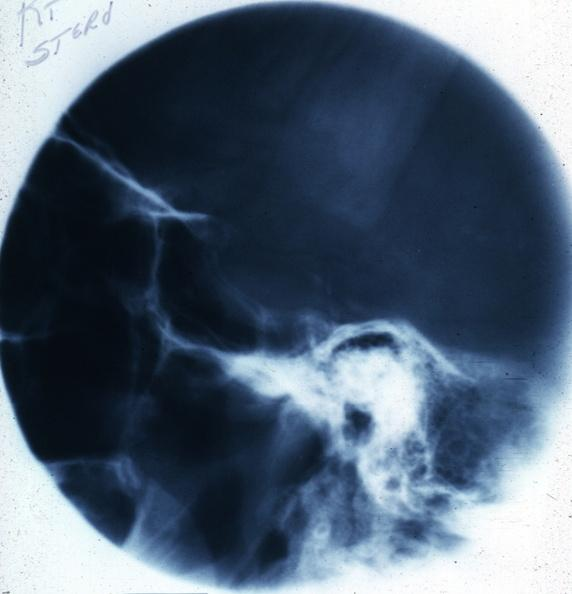what is present?
Answer the question using a single word or phrase. Chromophobe adenoma 